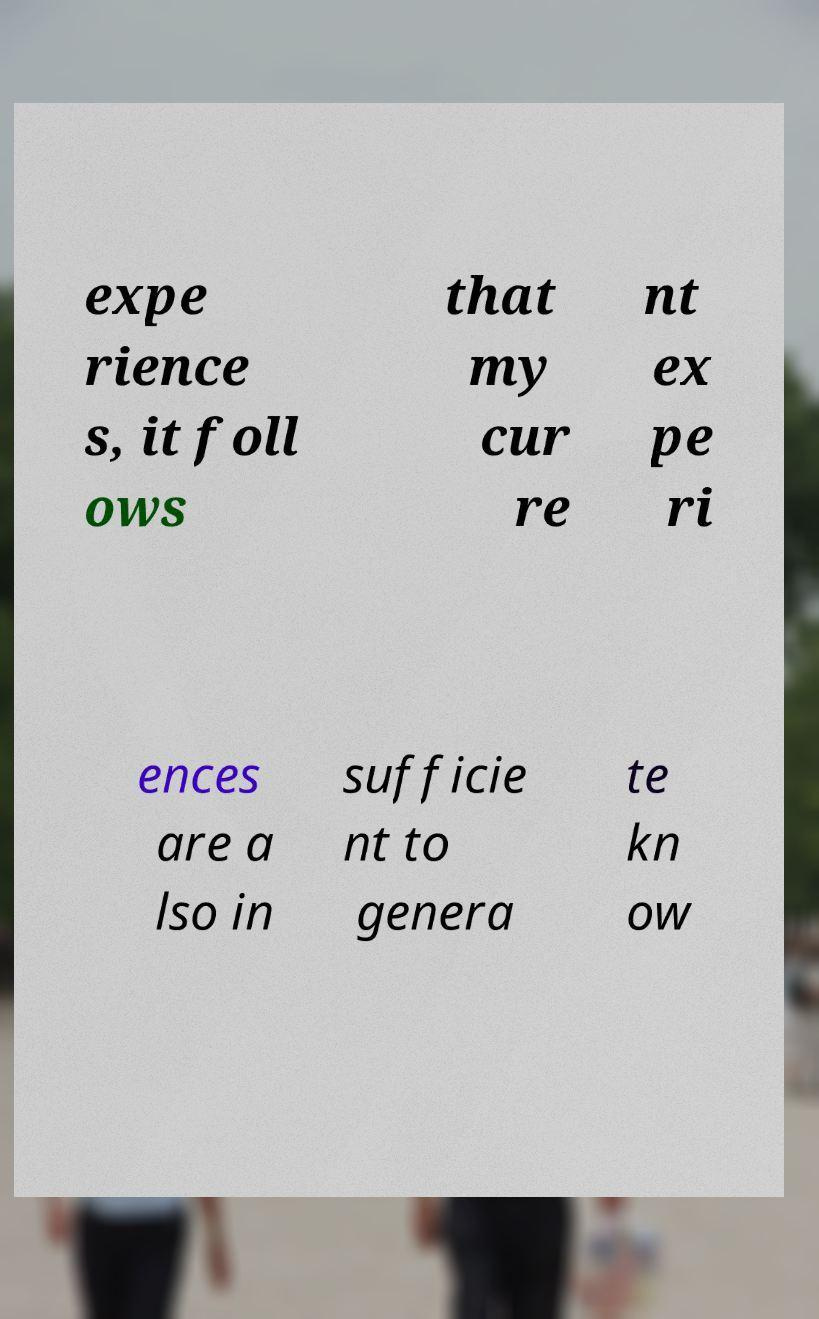Please read and relay the text visible in this image. What does it say? expe rience s, it foll ows that my cur re nt ex pe ri ences are a lso in sufficie nt to genera te kn ow 